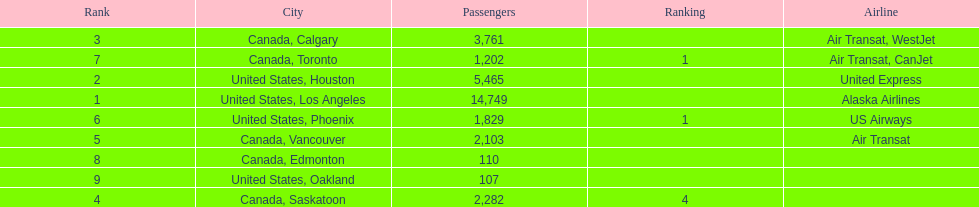Was los angeles or houston the busiest international route at manzanillo international airport in 2013? Los Angeles. 